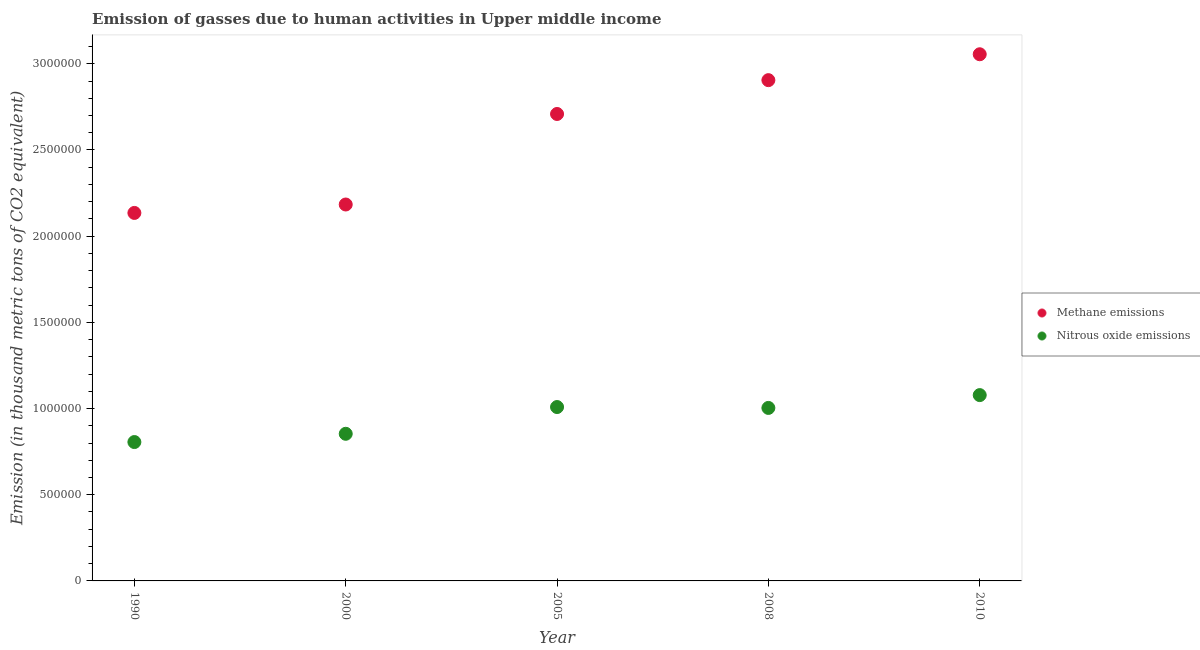Is the number of dotlines equal to the number of legend labels?
Your response must be concise. Yes. What is the amount of methane emissions in 2000?
Provide a succinct answer. 2.18e+06. Across all years, what is the maximum amount of methane emissions?
Provide a succinct answer. 3.06e+06. Across all years, what is the minimum amount of methane emissions?
Offer a very short reply. 2.13e+06. What is the total amount of nitrous oxide emissions in the graph?
Provide a succinct answer. 4.75e+06. What is the difference between the amount of methane emissions in 2005 and that in 2010?
Your answer should be compact. -3.46e+05. What is the difference between the amount of nitrous oxide emissions in 1990 and the amount of methane emissions in 2005?
Provide a short and direct response. -1.90e+06. What is the average amount of methane emissions per year?
Your answer should be compact. 2.60e+06. In the year 2008, what is the difference between the amount of nitrous oxide emissions and amount of methane emissions?
Your answer should be compact. -1.90e+06. What is the ratio of the amount of methane emissions in 2000 to that in 2010?
Offer a terse response. 0.71. Is the amount of nitrous oxide emissions in 2005 less than that in 2010?
Your answer should be very brief. Yes. What is the difference between the highest and the second highest amount of nitrous oxide emissions?
Your response must be concise. 6.92e+04. What is the difference between the highest and the lowest amount of nitrous oxide emissions?
Your answer should be compact. 2.72e+05. Is the sum of the amount of nitrous oxide emissions in 1990 and 2005 greater than the maximum amount of methane emissions across all years?
Give a very brief answer. No. Does the amount of nitrous oxide emissions monotonically increase over the years?
Keep it short and to the point. No. Is the amount of methane emissions strictly greater than the amount of nitrous oxide emissions over the years?
Ensure brevity in your answer.  Yes. Is the amount of methane emissions strictly less than the amount of nitrous oxide emissions over the years?
Ensure brevity in your answer.  No. How many dotlines are there?
Provide a short and direct response. 2. Does the graph contain grids?
Ensure brevity in your answer.  No. What is the title of the graph?
Give a very brief answer. Emission of gasses due to human activities in Upper middle income. Does "Secondary education" appear as one of the legend labels in the graph?
Keep it short and to the point. No. What is the label or title of the X-axis?
Your response must be concise. Year. What is the label or title of the Y-axis?
Your answer should be very brief. Emission (in thousand metric tons of CO2 equivalent). What is the Emission (in thousand metric tons of CO2 equivalent) of Methane emissions in 1990?
Your response must be concise. 2.13e+06. What is the Emission (in thousand metric tons of CO2 equivalent) in Nitrous oxide emissions in 1990?
Offer a very short reply. 8.06e+05. What is the Emission (in thousand metric tons of CO2 equivalent) of Methane emissions in 2000?
Ensure brevity in your answer.  2.18e+06. What is the Emission (in thousand metric tons of CO2 equivalent) of Nitrous oxide emissions in 2000?
Make the answer very short. 8.54e+05. What is the Emission (in thousand metric tons of CO2 equivalent) in Methane emissions in 2005?
Give a very brief answer. 2.71e+06. What is the Emission (in thousand metric tons of CO2 equivalent) of Nitrous oxide emissions in 2005?
Offer a terse response. 1.01e+06. What is the Emission (in thousand metric tons of CO2 equivalent) in Methane emissions in 2008?
Offer a very short reply. 2.91e+06. What is the Emission (in thousand metric tons of CO2 equivalent) of Nitrous oxide emissions in 2008?
Offer a very short reply. 1.00e+06. What is the Emission (in thousand metric tons of CO2 equivalent) in Methane emissions in 2010?
Provide a short and direct response. 3.06e+06. What is the Emission (in thousand metric tons of CO2 equivalent) in Nitrous oxide emissions in 2010?
Keep it short and to the point. 1.08e+06. Across all years, what is the maximum Emission (in thousand metric tons of CO2 equivalent) in Methane emissions?
Your response must be concise. 3.06e+06. Across all years, what is the maximum Emission (in thousand metric tons of CO2 equivalent) in Nitrous oxide emissions?
Your response must be concise. 1.08e+06. Across all years, what is the minimum Emission (in thousand metric tons of CO2 equivalent) in Methane emissions?
Keep it short and to the point. 2.13e+06. Across all years, what is the minimum Emission (in thousand metric tons of CO2 equivalent) of Nitrous oxide emissions?
Offer a very short reply. 8.06e+05. What is the total Emission (in thousand metric tons of CO2 equivalent) in Methane emissions in the graph?
Your answer should be compact. 1.30e+07. What is the total Emission (in thousand metric tons of CO2 equivalent) of Nitrous oxide emissions in the graph?
Make the answer very short. 4.75e+06. What is the difference between the Emission (in thousand metric tons of CO2 equivalent) in Methane emissions in 1990 and that in 2000?
Your answer should be compact. -4.89e+04. What is the difference between the Emission (in thousand metric tons of CO2 equivalent) in Nitrous oxide emissions in 1990 and that in 2000?
Keep it short and to the point. -4.79e+04. What is the difference between the Emission (in thousand metric tons of CO2 equivalent) of Methane emissions in 1990 and that in 2005?
Offer a terse response. -5.74e+05. What is the difference between the Emission (in thousand metric tons of CO2 equivalent) in Nitrous oxide emissions in 1990 and that in 2005?
Offer a terse response. -2.03e+05. What is the difference between the Emission (in thousand metric tons of CO2 equivalent) of Methane emissions in 1990 and that in 2008?
Offer a very short reply. -7.70e+05. What is the difference between the Emission (in thousand metric tons of CO2 equivalent) of Nitrous oxide emissions in 1990 and that in 2008?
Make the answer very short. -1.98e+05. What is the difference between the Emission (in thousand metric tons of CO2 equivalent) in Methane emissions in 1990 and that in 2010?
Offer a terse response. -9.20e+05. What is the difference between the Emission (in thousand metric tons of CO2 equivalent) in Nitrous oxide emissions in 1990 and that in 2010?
Provide a short and direct response. -2.72e+05. What is the difference between the Emission (in thousand metric tons of CO2 equivalent) in Methane emissions in 2000 and that in 2005?
Your response must be concise. -5.25e+05. What is the difference between the Emission (in thousand metric tons of CO2 equivalent) in Nitrous oxide emissions in 2000 and that in 2005?
Your answer should be very brief. -1.55e+05. What is the difference between the Emission (in thousand metric tons of CO2 equivalent) in Methane emissions in 2000 and that in 2008?
Make the answer very short. -7.21e+05. What is the difference between the Emission (in thousand metric tons of CO2 equivalent) of Nitrous oxide emissions in 2000 and that in 2008?
Your response must be concise. -1.50e+05. What is the difference between the Emission (in thousand metric tons of CO2 equivalent) in Methane emissions in 2000 and that in 2010?
Offer a terse response. -8.72e+05. What is the difference between the Emission (in thousand metric tons of CO2 equivalent) in Nitrous oxide emissions in 2000 and that in 2010?
Your response must be concise. -2.24e+05. What is the difference between the Emission (in thousand metric tons of CO2 equivalent) in Methane emissions in 2005 and that in 2008?
Your response must be concise. -1.96e+05. What is the difference between the Emission (in thousand metric tons of CO2 equivalent) of Nitrous oxide emissions in 2005 and that in 2008?
Provide a succinct answer. 5159.9. What is the difference between the Emission (in thousand metric tons of CO2 equivalent) in Methane emissions in 2005 and that in 2010?
Your response must be concise. -3.46e+05. What is the difference between the Emission (in thousand metric tons of CO2 equivalent) of Nitrous oxide emissions in 2005 and that in 2010?
Offer a very short reply. -6.92e+04. What is the difference between the Emission (in thousand metric tons of CO2 equivalent) in Methane emissions in 2008 and that in 2010?
Ensure brevity in your answer.  -1.50e+05. What is the difference between the Emission (in thousand metric tons of CO2 equivalent) of Nitrous oxide emissions in 2008 and that in 2010?
Give a very brief answer. -7.44e+04. What is the difference between the Emission (in thousand metric tons of CO2 equivalent) in Methane emissions in 1990 and the Emission (in thousand metric tons of CO2 equivalent) in Nitrous oxide emissions in 2000?
Offer a terse response. 1.28e+06. What is the difference between the Emission (in thousand metric tons of CO2 equivalent) of Methane emissions in 1990 and the Emission (in thousand metric tons of CO2 equivalent) of Nitrous oxide emissions in 2005?
Your answer should be compact. 1.13e+06. What is the difference between the Emission (in thousand metric tons of CO2 equivalent) in Methane emissions in 1990 and the Emission (in thousand metric tons of CO2 equivalent) in Nitrous oxide emissions in 2008?
Keep it short and to the point. 1.13e+06. What is the difference between the Emission (in thousand metric tons of CO2 equivalent) of Methane emissions in 1990 and the Emission (in thousand metric tons of CO2 equivalent) of Nitrous oxide emissions in 2010?
Offer a terse response. 1.06e+06. What is the difference between the Emission (in thousand metric tons of CO2 equivalent) in Methane emissions in 2000 and the Emission (in thousand metric tons of CO2 equivalent) in Nitrous oxide emissions in 2005?
Give a very brief answer. 1.17e+06. What is the difference between the Emission (in thousand metric tons of CO2 equivalent) in Methane emissions in 2000 and the Emission (in thousand metric tons of CO2 equivalent) in Nitrous oxide emissions in 2008?
Ensure brevity in your answer.  1.18e+06. What is the difference between the Emission (in thousand metric tons of CO2 equivalent) in Methane emissions in 2000 and the Emission (in thousand metric tons of CO2 equivalent) in Nitrous oxide emissions in 2010?
Make the answer very short. 1.11e+06. What is the difference between the Emission (in thousand metric tons of CO2 equivalent) of Methane emissions in 2005 and the Emission (in thousand metric tons of CO2 equivalent) of Nitrous oxide emissions in 2008?
Keep it short and to the point. 1.71e+06. What is the difference between the Emission (in thousand metric tons of CO2 equivalent) of Methane emissions in 2005 and the Emission (in thousand metric tons of CO2 equivalent) of Nitrous oxide emissions in 2010?
Your answer should be compact. 1.63e+06. What is the difference between the Emission (in thousand metric tons of CO2 equivalent) of Methane emissions in 2008 and the Emission (in thousand metric tons of CO2 equivalent) of Nitrous oxide emissions in 2010?
Offer a terse response. 1.83e+06. What is the average Emission (in thousand metric tons of CO2 equivalent) of Methane emissions per year?
Provide a short and direct response. 2.60e+06. What is the average Emission (in thousand metric tons of CO2 equivalent) of Nitrous oxide emissions per year?
Keep it short and to the point. 9.50e+05. In the year 1990, what is the difference between the Emission (in thousand metric tons of CO2 equivalent) in Methane emissions and Emission (in thousand metric tons of CO2 equivalent) in Nitrous oxide emissions?
Offer a very short reply. 1.33e+06. In the year 2000, what is the difference between the Emission (in thousand metric tons of CO2 equivalent) in Methane emissions and Emission (in thousand metric tons of CO2 equivalent) in Nitrous oxide emissions?
Offer a very short reply. 1.33e+06. In the year 2005, what is the difference between the Emission (in thousand metric tons of CO2 equivalent) of Methane emissions and Emission (in thousand metric tons of CO2 equivalent) of Nitrous oxide emissions?
Keep it short and to the point. 1.70e+06. In the year 2008, what is the difference between the Emission (in thousand metric tons of CO2 equivalent) in Methane emissions and Emission (in thousand metric tons of CO2 equivalent) in Nitrous oxide emissions?
Your answer should be compact. 1.90e+06. In the year 2010, what is the difference between the Emission (in thousand metric tons of CO2 equivalent) of Methane emissions and Emission (in thousand metric tons of CO2 equivalent) of Nitrous oxide emissions?
Keep it short and to the point. 1.98e+06. What is the ratio of the Emission (in thousand metric tons of CO2 equivalent) in Methane emissions in 1990 to that in 2000?
Provide a short and direct response. 0.98. What is the ratio of the Emission (in thousand metric tons of CO2 equivalent) of Nitrous oxide emissions in 1990 to that in 2000?
Offer a very short reply. 0.94. What is the ratio of the Emission (in thousand metric tons of CO2 equivalent) in Methane emissions in 1990 to that in 2005?
Provide a short and direct response. 0.79. What is the ratio of the Emission (in thousand metric tons of CO2 equivalent) of Nitrous oxide emissions in 1990 to that in 2005?
Make the answer very short. 0.8. What is the ratio of the Emission (in thousand metric tons of CO2 equivalent) of Methane emissions in 1990 to that in 2008?
Ensure brevity in your answer.  0.73. What is the ratio of the Emission (in thousand metric tons of CO2 equivalent) of Nitrous oxide emissions in 1990 to that in 2008?
Ensure brevity in your answer.  0.8. What is the ratio of the Emission (in thousand metric tons of CO2 equivalent) in Methane emissions in 1990 to that in 2010?
Ensure brevity in your answer.  0.7. What is the ratio of the Emission (in thousand metric tons of CO2 equivalent) in Nitrous oxide emissions in 1990 to that in 2010?
Give a very brief answer. 0.75. What is the ratio of the Emission (in thousand metric tons of CO2 equivalent) in Methane emissions in 2000 to that in 2005?
Provide a short and direct response. 0.81. What is the ratio of the Emission (in thousand metric tons of CO2 equivalent) of Nitrous oxide emissions in 2000 to that in 2005?
Your answer should be compact. 0.85. What is the ratio of the Emission (in thousand metric tons of CO2 equivalent) of Methane emissions in 2000 to that in 2008?
Give a very brief answer. 0.75. What is the ratio of the Emission (in thousand metric tons of CO2 equivalent) in Nitrous oxide emissions in 2000 to that in 2008?
Keep it short and to the point. 0.85. What is the ratio of the Emission (in thousand metric tons of CO2 equivalent) of Methane emissions in 2000 to that in 2010?
Ensure brevity in your answer.  0.71. What is the ratio of the Emission (in thousand metric tons of CO2 equivalent) of Nitrous oxide emissions in 2000 to that in 2010?
Make the answer very short. 0.79. What is the ratio of the Emission (in thousand metric tons of CO2 equivalent) of Methane emissions in 2005 to that in 2008?
Your response must be concise. 0.93. What is the ratio of the Emission (in thousand metric tons of CO2 equivalent) of Methane emissions in 2005 to that in 2010?
Offer a terse response. 0.89. What is the ratio of the Emission (in thousand metric tons of CO2 equivalent) in Nitrous oxide emissions in 2005 to that in 2010?
Make the answer very short. 0.94. What is the ratio of the Emission (in thousand metric tons of CO2 equivalent) in Methane emissions in 2008 to that in 2010?
Your response must be concise. 0.95. What is the ratio of the Emission (in thousand metric tons of CO2 equivalent) of Nitrous oxide emissions in 2008 to that in 2010?
Give a very brief answer. 0.93. What is the difference between the highest and the second highest Emission (in thousand metric tons of CO2 equivalent) in Methane emissions?
Your answer should be compact. 1.50e+05. What is the difference between the highest and the second highest Emission (in thousand metric tons of CO2 equivalent) in Nitrous oxide emissions?
Your answer should be very brief. 6.92e+04. What is the difference between the highest and the lowest Emission (in thousand metric tons of CO2 equivalent) of Methane emissions?
Provide a short and direct response. 9.20e+05. What is the difference between the highest and the lowest Emission (in thousand metric tons of CO2 equivalent) in Nitrous oxide emissions?
Give a very brief answer. 2.72e+05. 